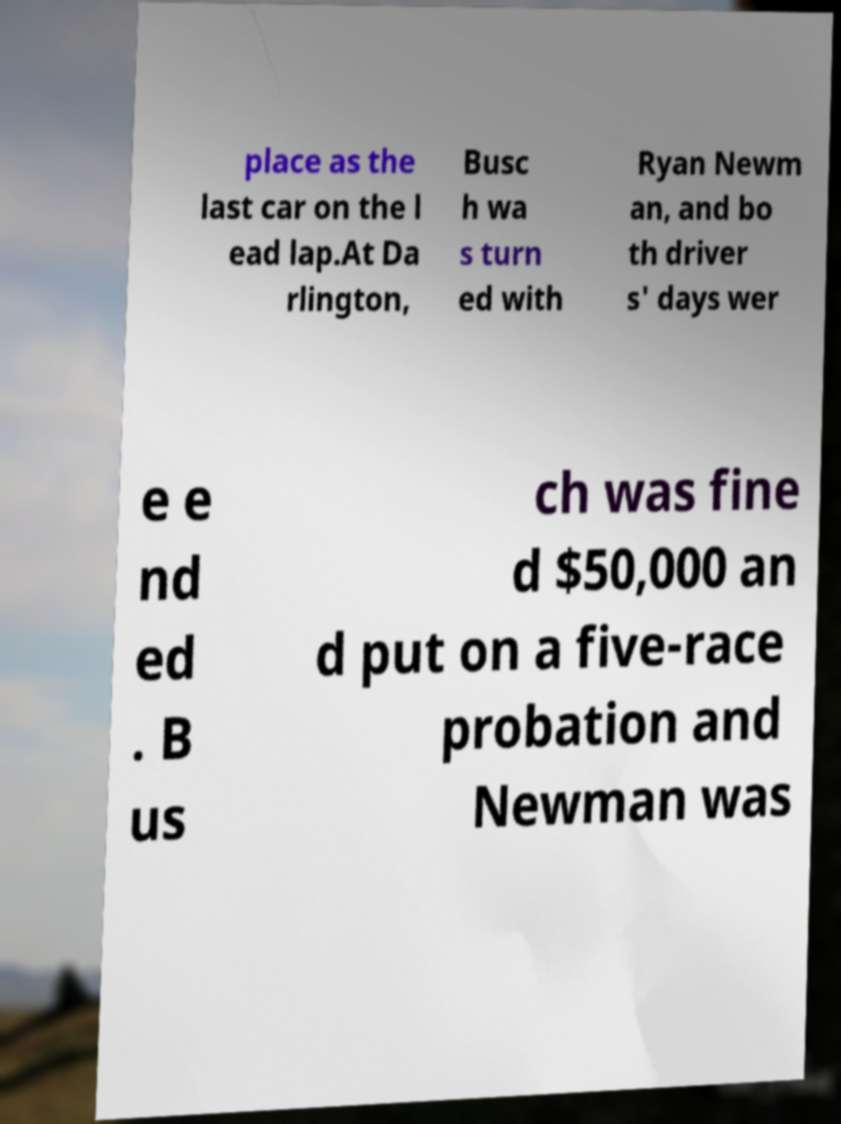Could you assist in decoding the text presented in this image and type it out clearly? place as the last car on the l ead lap.At Da rlington, Busc h wa s turn ed with Ryan Newm an, and bo th driver s' days wer e e nd ed . B us ch was fine d $50,000 an d put on a five-race probation and Newman was 